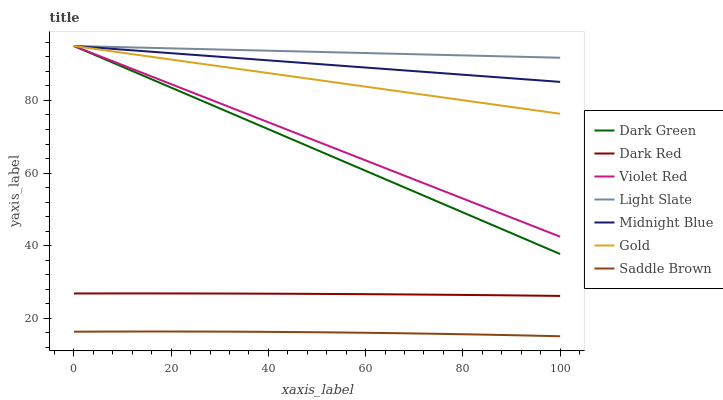Does Saddle Brown have the minimum area under the curve?
Answer yes or no. Yes. Does Light Slate have the maximum area under the curve?
Answer yes or no. Yes. Does Midnight Blue have the minimum area under the curve?
Answer yes or no. No. Does Midnight Blue have the maximum area under the curve?
Answer yes or no. No. Is Violet Red the smoothest?
Answer yes or no. Yes. Is Saddle Brown the roughest?
Answer yes or no. Yes. Is Midnight Blue the smoothest?
Answer yes or no. No. Is Midnight Blue the roughest?
Answer yes or no. No. Does Midnight Blue have the lowest value?
Answer yes or no. No. Does Dark Green have the highest value?
Answer yes or no. Yes. Does Dark Red have the highest value?
Answer yes or no. No. Is Saddle Brown less than Midnight Blue?
Answer yes or no. Yes. Is Violet Red greater than Dark Red?
Answer yes or no. Yes. Does Gold intersect Violet Red?
Answer yes or no. Yes. Is Gold less than Violet Red?
Answer yes or no. No. Is Gold greater than Violet Red?
Answer yes or no. No. Does Saddle Brown intersect Midnight Blue?
Answer yes or no. No. 